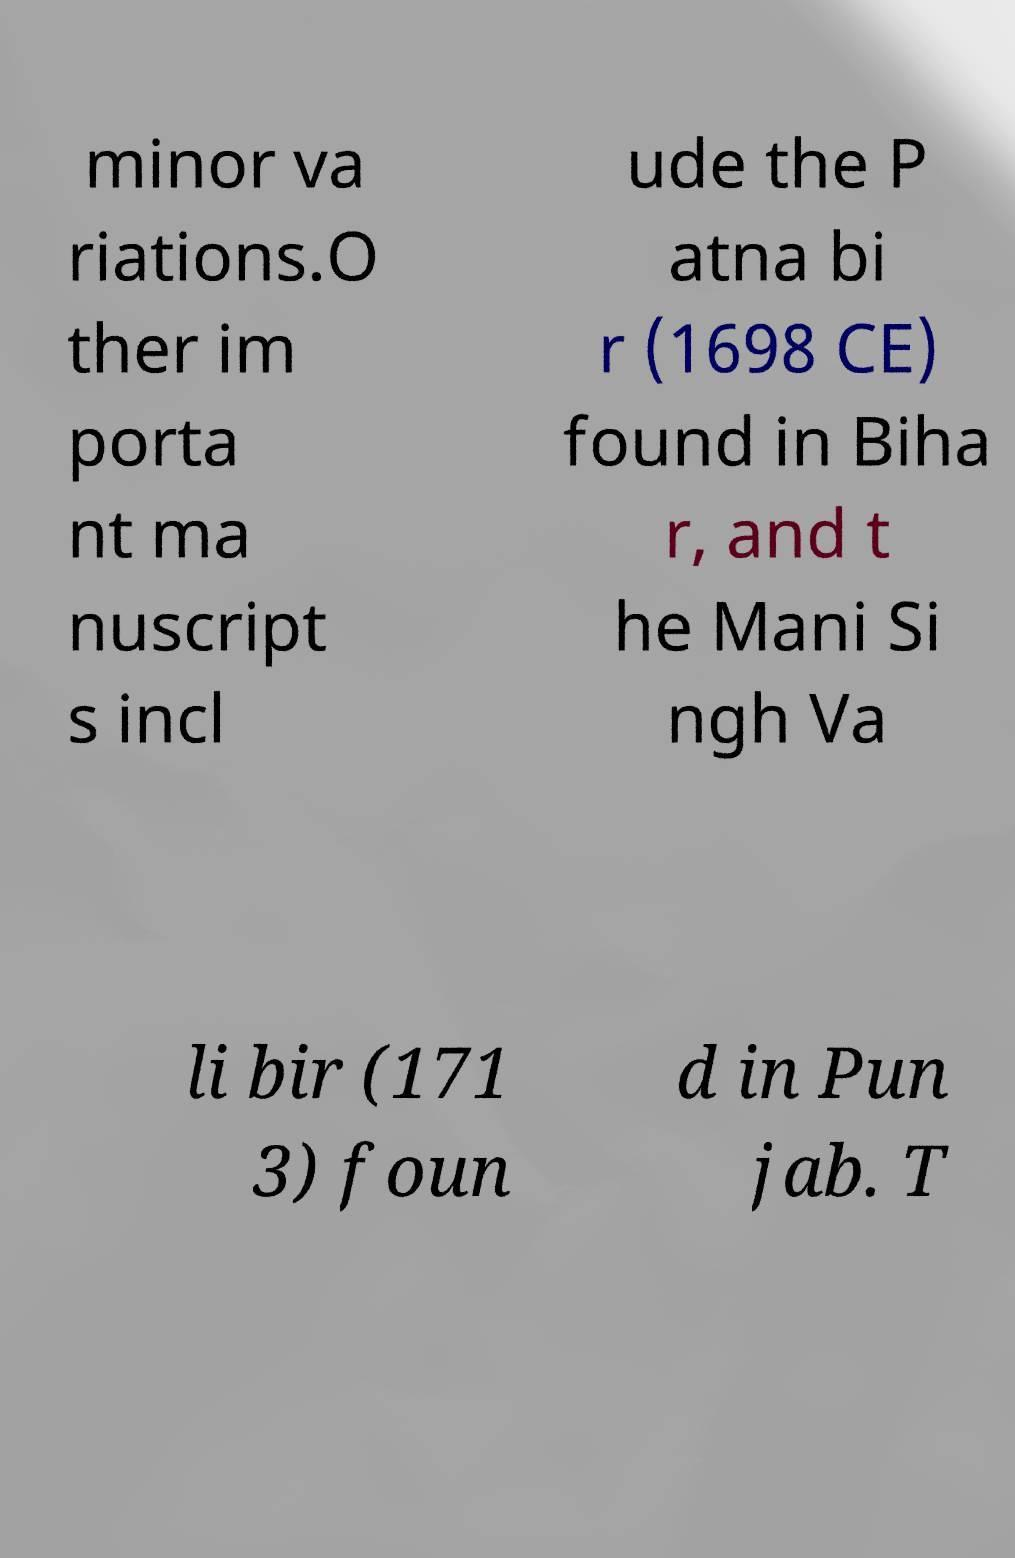Please read and relay the text visible in this image. What does it say? minor va riations.O ther im porta nt ma nuscript s incl ude the P atna bi r (1698 CE) found in Biha r, and t he Mani Si ngh Va li bir (171 3) foun d in Pun jab. T 